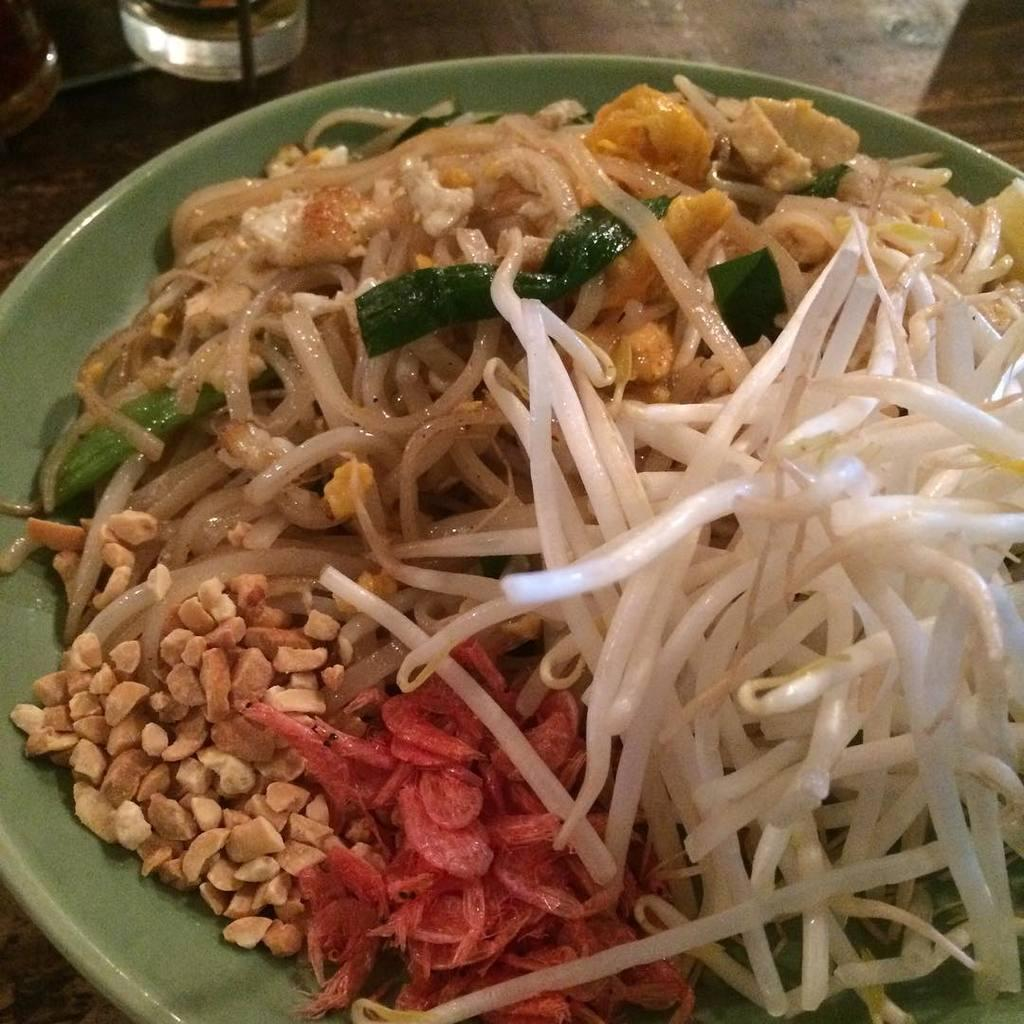What is on the plate that is visible in the image? There is food on a plate in the image. What else can be seen on the table besides the plate? There are glasses visible in the image. Where are the plate and glasses located in the image? The plate and glasses are placed on a table. What type of song is being played in the background of the image? There is no indication of any music or song being played in the image. 